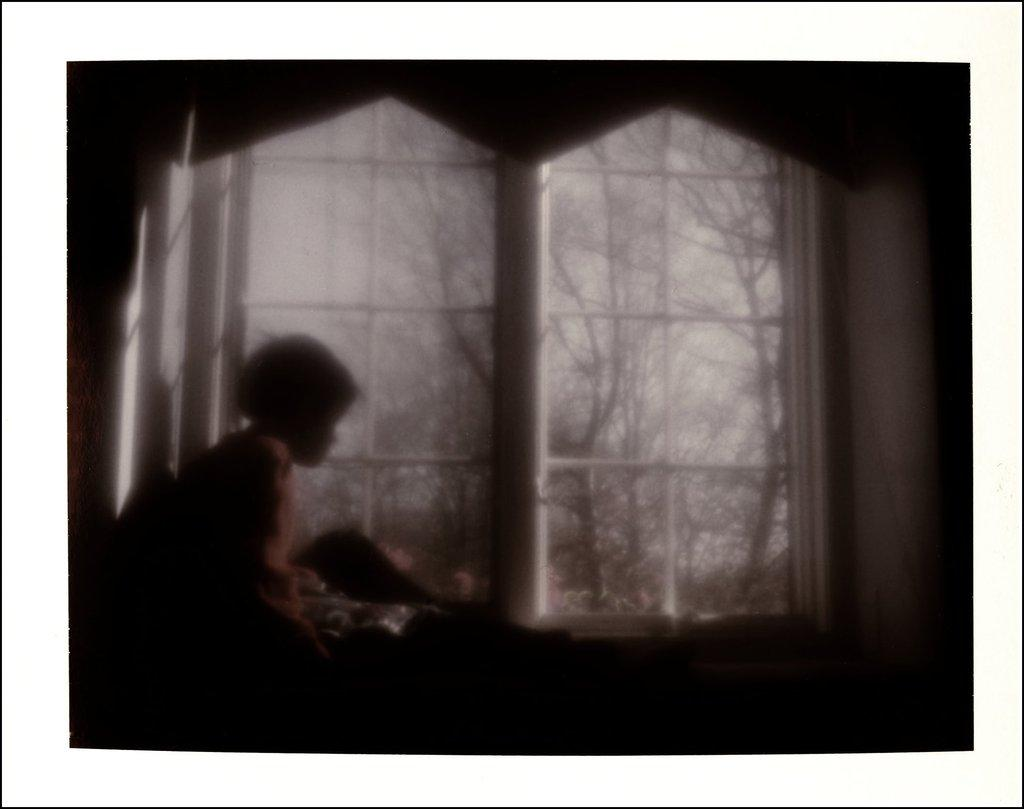Who is the main subject in the image? There is a small girl in the image. Where is the girl located in the image? The girl is on the left side of the image. What is in front of the girl? There is a window in front of the girl. What can be seen outside the window? Trees are visible outside the window. What type of comb is the girl using to butter her bikes in the image? There are no bikes, comb, or butter present in the image. 